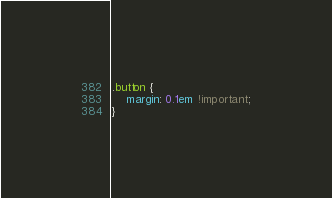<code> <loc_0><loc_0><loc_500><loc_500><_CSS_>.button {
    margin: 0.1em !important;
}</code> 